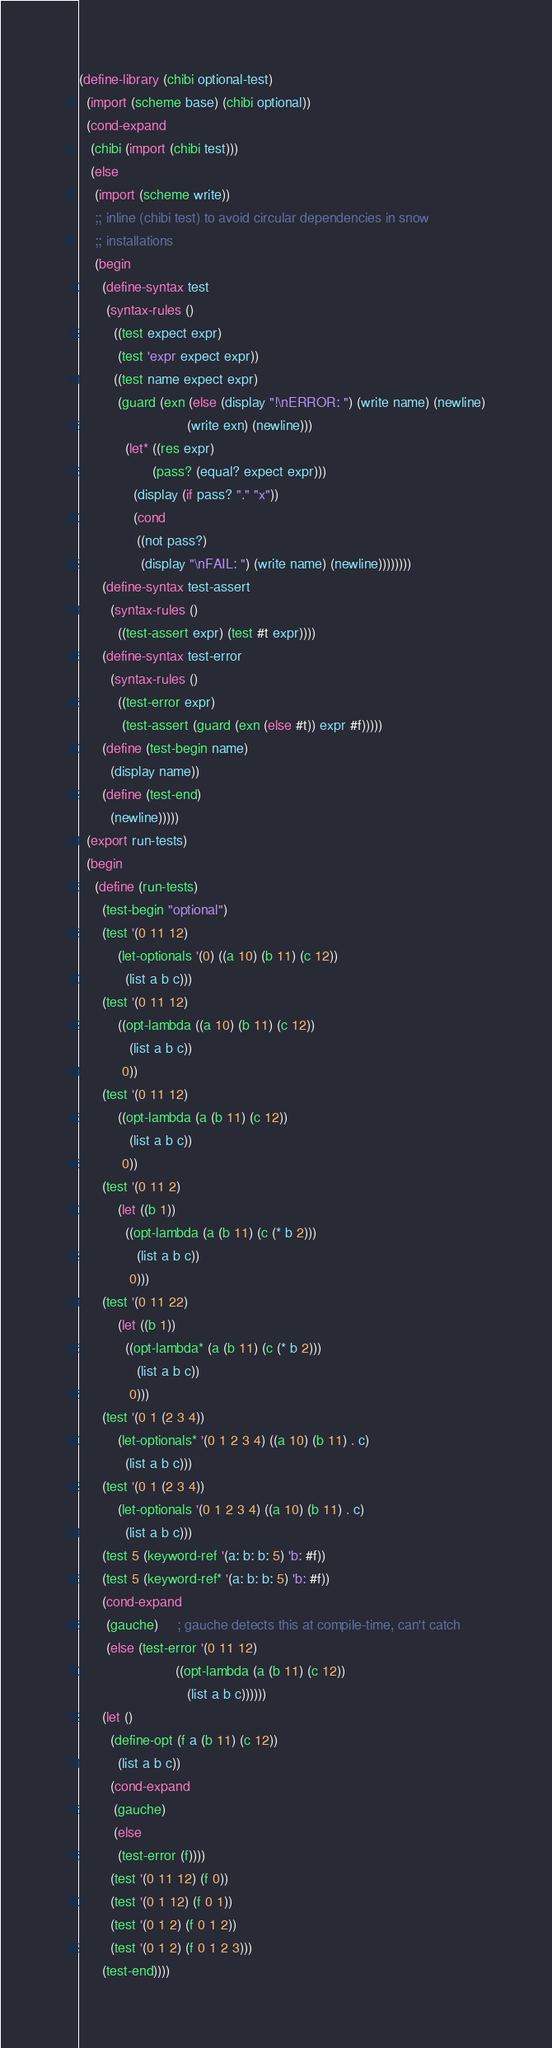Convert code to text. <code><loc_0><loc_0><loc_500><loc_500><_Scheme_>
(define-library (chibi optional-test)
  (import (scheme base) (chibi optional))
  (cond-expand
   (chibi (import (chibi test)))
   (else
    (import (scheme write))
    ;; inline (chibi test) to avoid circular dependencies in snow
    ;; installations
    (begin
      (define-syntax test
       (syntax-rules ()
         ((test expect expr)
          (test 'expr expect expr))
         ((test name expect expr)
          (guard (exn (else (display "!\nERROR: ") (write name) (newline)
                            (write exn) (newline)))
            (let* ((res expr)
                   (pass? (equal? expect expr)))
              (display (if pass? "." "x"))
              (cond
               ((not pass?)
                (display "\nFAIL: ") (write name) (newline))))))))
      (define-syntax test-assert
        (syntax-rules ()
          ((test-assert expr) (test #t expr))))
      (define-syntax test-error
        (syntax-rules ()
          ((test-error expr)
           (test-assert (guard (exn (else #t)) expr #f)))))
      (define (test-begin name)
        (display name))
      (define (test-end)
        (newline)))))
  (export run-tests)
  (begin
    (define (run-tests)
      (test-begin "optional")
      (test '(0 11 12)
          (let-optionals '(0) ((a 10) (b 11) (c 12))
            (list a b c)))
      (test '(0 11 12)
          ((opt-lambda ((a 10) (b 11) (c 12))
             (list a b c))
           0))
      (test '(0 11 12)
          ((opt-lambda (a (b 11) (c 12))
             (list a b c))
           0))
      (test '(0 11 2)
          (let ((b 1))
            ((opt-lambda (a (b 11) (c (* b 2)))
               (list a b c))
             0)))
      (test '(0 11 22)
          (let ((b 1))
            ((opt-lambda* (a (b 11) (c (* b 2)))
               (list a b c))
             0)))
      (test '(0 1 (2 3 4))
          (let-optionals* '(0 1 2 3 4) ((a 10) (b 11) . c)
            (list a b c)))
      (test '(0 1 (2 3 4))
          (let-optionals '(0 1 2 3 4) ((a 10) (b 11) . c)
            (list a b c)))
      (test 5 (keyword-ref '(a: b: b: 5) 'b: #f))
      (test 5 (keyword-ref* '(a: b: b: 5) 'b: #f))
      (cond-expand
       (gauche)     ; gauche detects this at compile-time, can't catch
       (else (test-error '(0 11 12)
                         ((opt-lambda (a (b 11) (c 12))
                            (list a b c))))))
      (let ()
        (define-opt (f a (b 11) (c 12))
          (list a b c))
        (cond-expand
         (gauche)
         (else
          (test-error (f))))
        (test '(0 11 12) (f 0))
        (test '(0 1 12) (f 0 1))
        (test '(0 1 2) (f 0 1 2))
        (test '(0 1 2) (f 0 1 2 3)))
      (test-end))))
</code> 